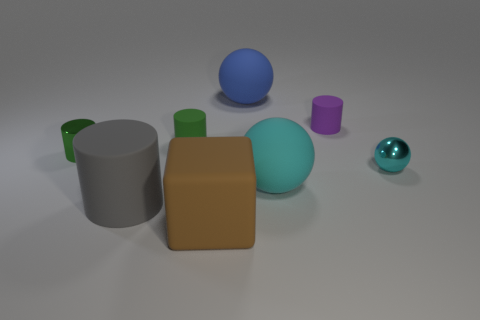There is a matte cylinder that is on the right side of the large matte thing behind the big cyan rubber ball; how big is it? The matte cylinder on the right side appears relatively small compared to the other objects in the image, specifically the larger shapes surrounding it. Its size is not dominant in the composition, indicating it might be considered small within this context. 